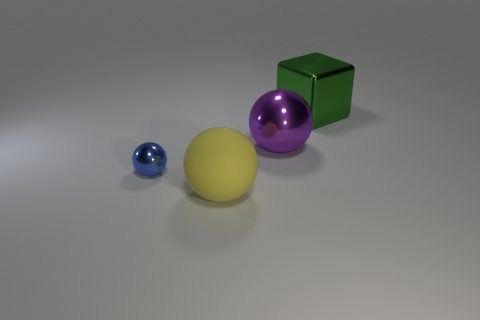Subtract all big matte balls. How many balls are left? 2 Add 1 cyan rubber spheres. How many objects exist? 5 Subtract all blocks. How many objects are left? 3 Subtract 1 cubes. How many cubes are left? 0 Subtract all brown balls. Subtract all red cubes. How many balls are left? 3 Add 1 tiny blue shiny things. How many tiny blue shiny things are left? 2 Add 4 cubes. How many cubes exist? 5 Subtract 1 yellow spheres. How many objects are left? 3 Subtract all cyan cylinders. How many yellow balls are left? 1 Subtract all big gray things. Subtract all cubes. How many objects are left? 3 